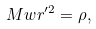<formula> <loc_0><loc_0><loc_500><loc_500>M w r ^ { \prime 2 } = \rho ,</formula> 